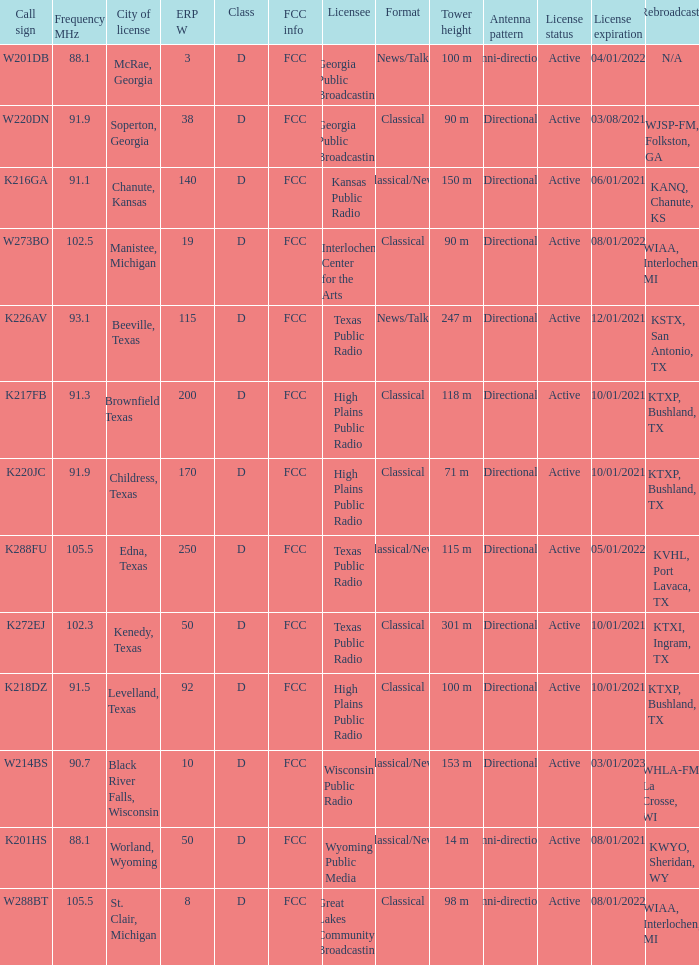What is Call Sign, when City of License is Brownfield, Texas? K217FB. 